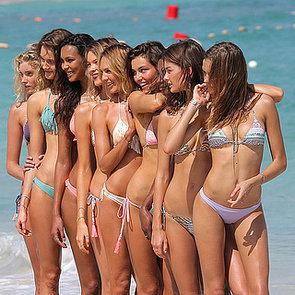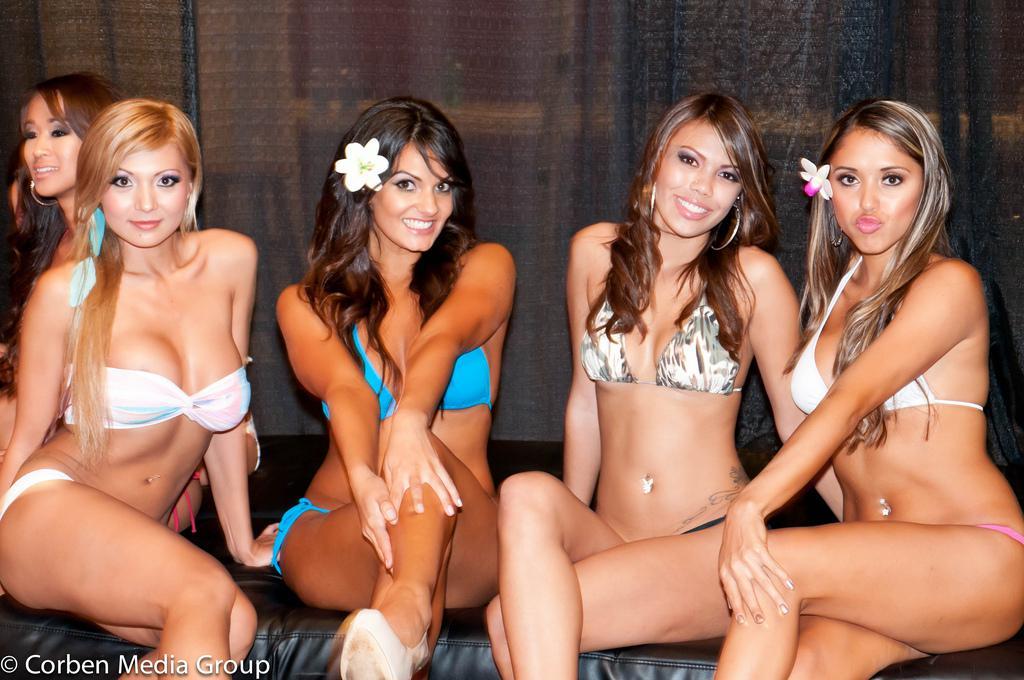The first image is the image on the left, the second image is the image on the right. Evaluate the accuracy of this statement regarding the images: "There are 6 women lined up for a photo in the left image.". Is it true? Answer yes or no. No. The first image is the image on the left, the second image is the image on the right. Given the left and right images, does the statement "The left and right image contains a total of 13 women in bikinis." hold true? Answer yes or no. Yes. 